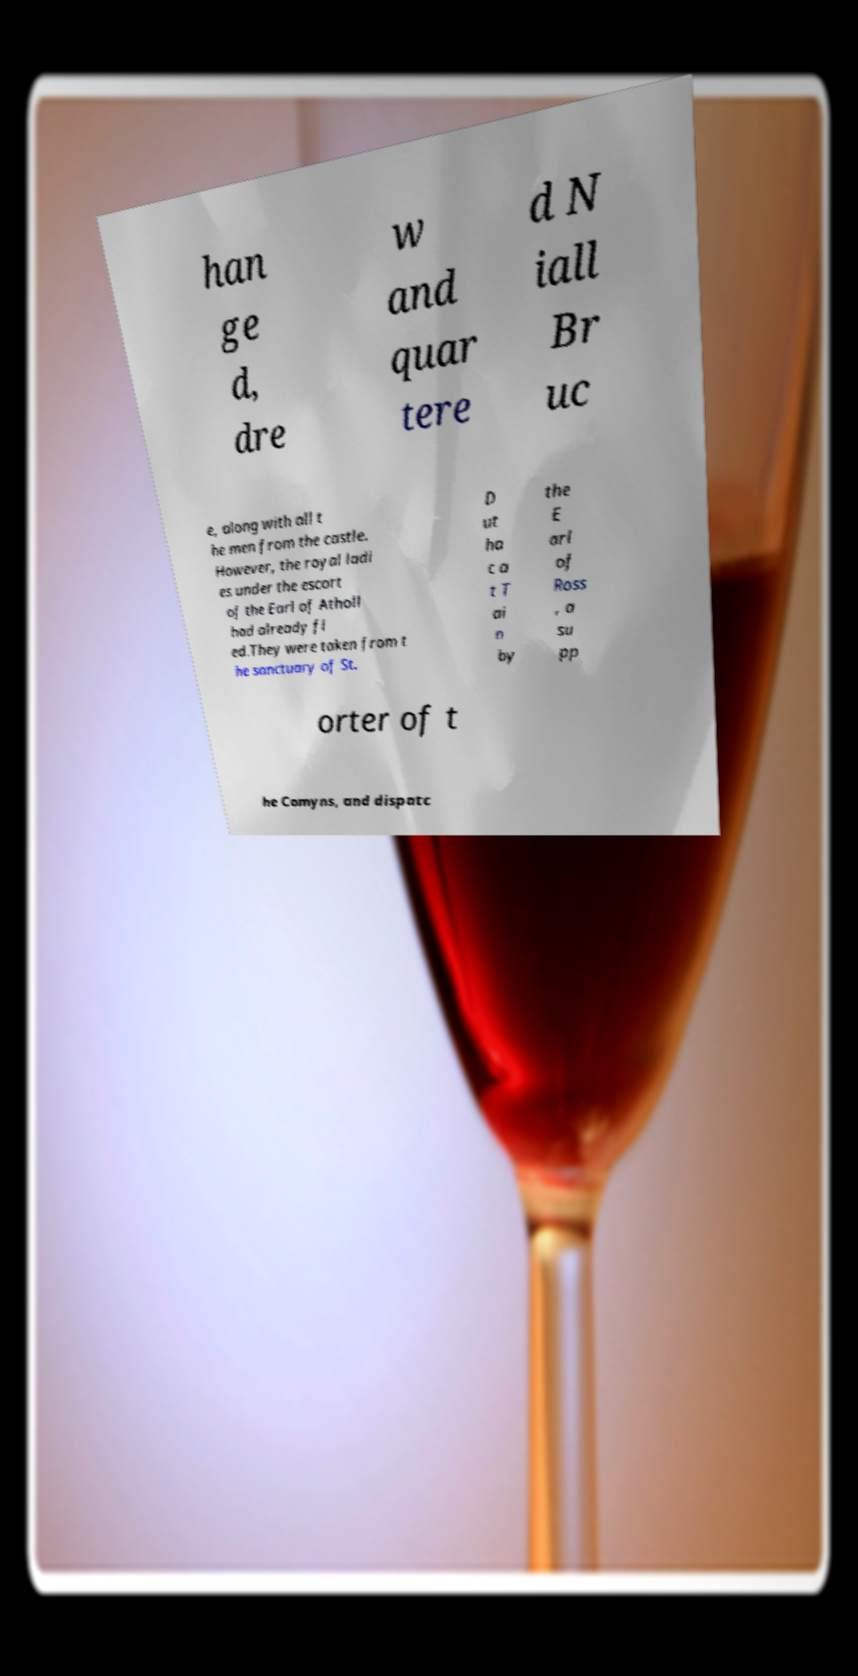There's text embedded in this image that I need extracted. Can you transcribe it verbatim? han ge d, dre w and quar tere d N iall Br uc e, along with all t he men from the castle. However, the royal ladi es under the escort of the Earl of Atholl had already fl ed.They were taken from t he sanctuary of St. D ut ha c a t T ai n by the E arl of Ross , a su pp orter of t he Comyns, and dispatc 